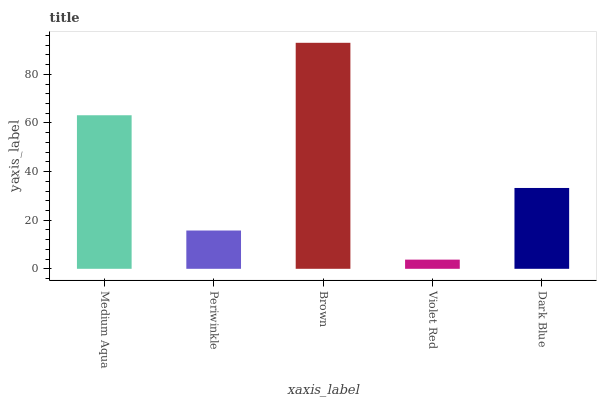Is Periwinkle the minimum?
Answer yes or no. No. Is Periwinkle the maximum?
Answer yes or no. No. Is Medium Aqua greater than Periwinkle?
Answer yes or no. Yes. Is Periwinkle less than Medium Aqua?
Answer yes or no. Yes. Is Periwinkle greater than Medium Aqua?
Answer yes or no. No. Is Medium Aqua less than Periwinkle?
Answer yes or no. No. Is Dark Blue the high median?
Answer yes or no. Yes. Is Dark Blue the low median?
Answer yes or no. Yes. Is Periwinkle the high median?
Answer yes or no. No. Is Periwinkle the low median?
Answer yes or no. No. 